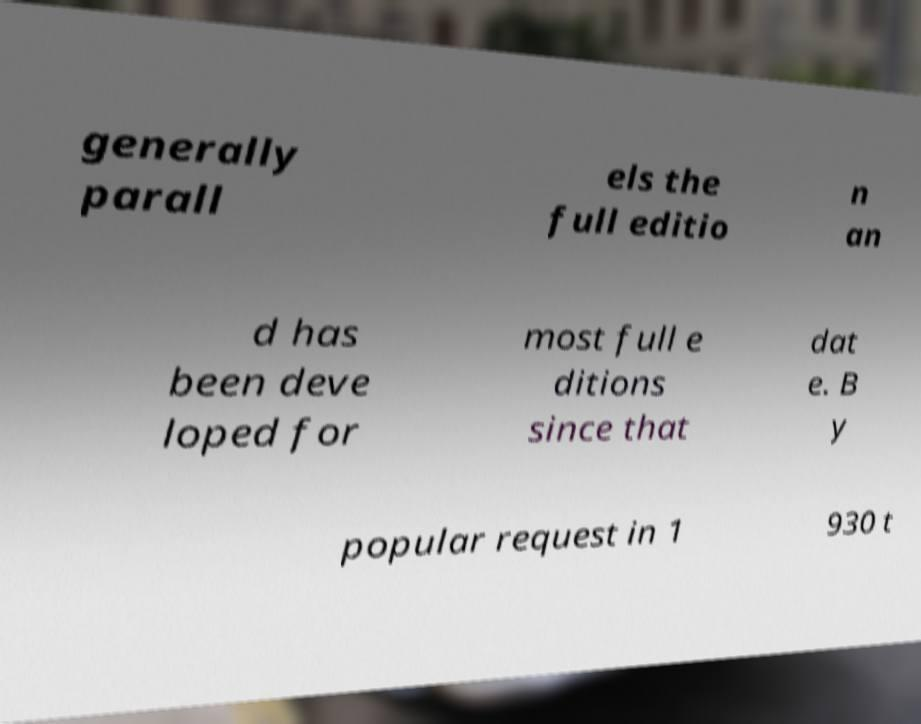Please read and relay the text visible in this image. What does it say? generally parall els the full editio n an d has been deve loped for most full e ditions since that dat e. B y popular request in 1 930 t 